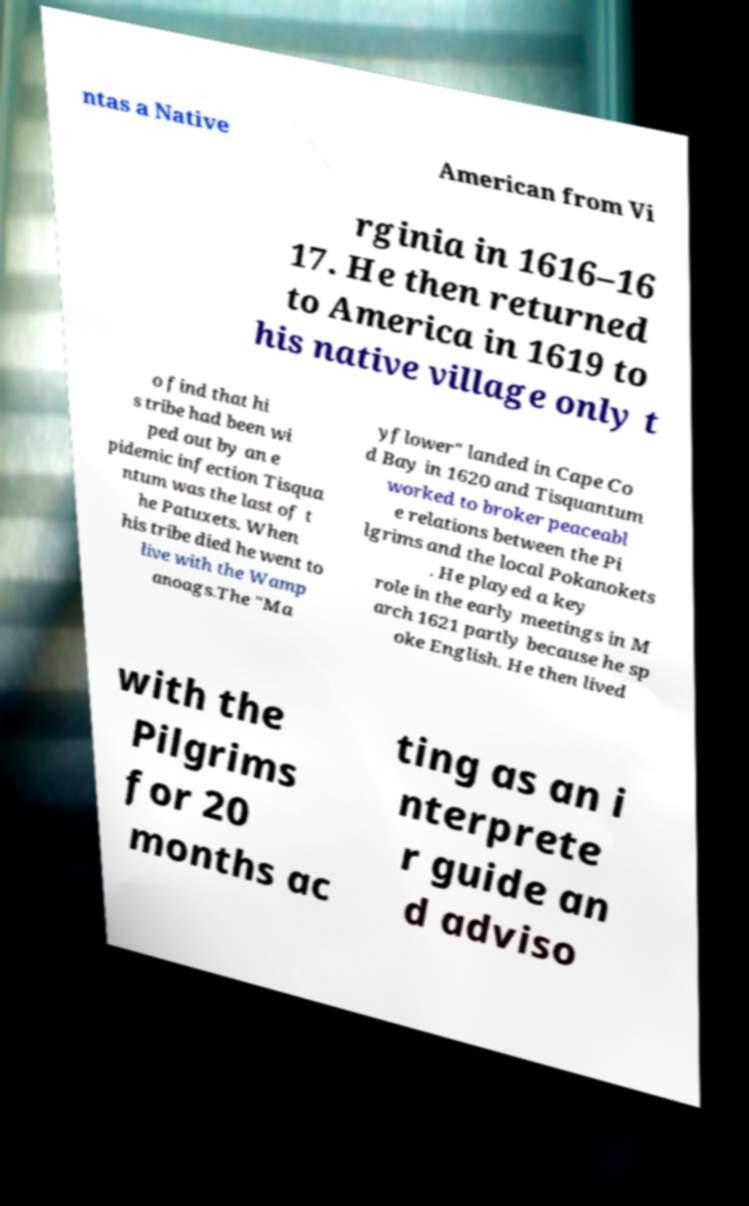What messages or text are displayed in this image? I need them in a readable, typed format. ntas a Native American from Vi rginia in 1616–16 17. He then returned to America in 1619 to his native village only t o find that hi s tribe had been wi ped out by an e pidemic infection Tisqua ntum was the last of t he Patuxets. When his tribe died he went to live with the Wamp anoags.The "Ma yflower" landed in Cape Co d Bay in 1620 and Tisquantum worked to broker peaceabl e relations between the Pi lgrims and the local Pokanokets . He played a key role in the early meetings in M arch 1621 partly because he sp oke English. He then lived with the Pilgrims for 20 months ac ting as an i nterprete r guide an d adviso 